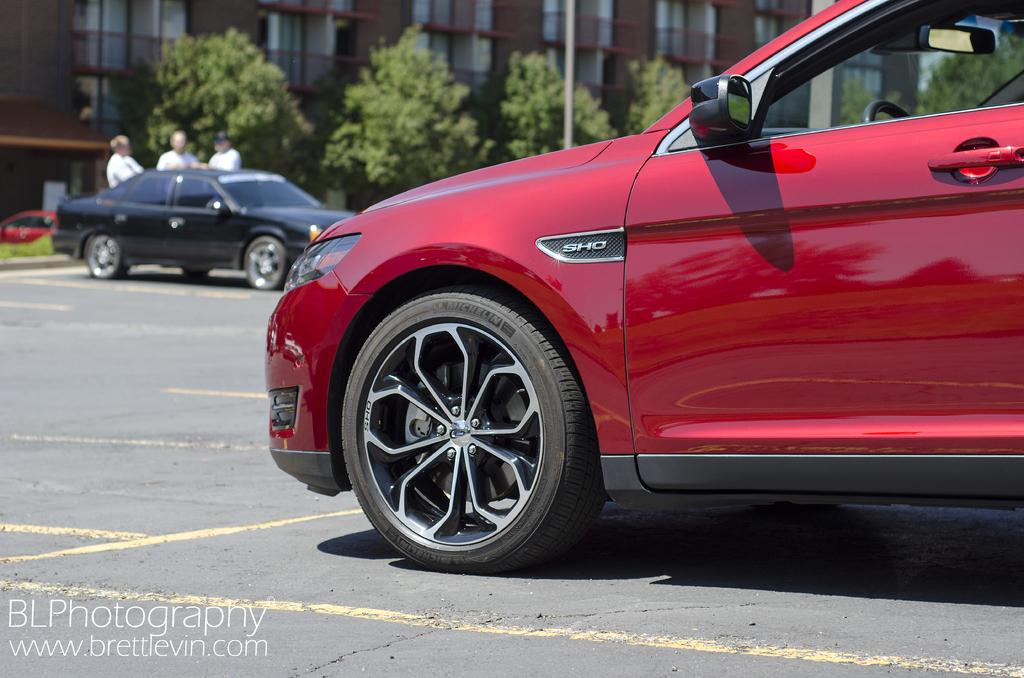What color is the car that is visible on the road in the image? The car on the road is red. What else can be seen on the road in the image? There are no other objects or vehicles visible on the road in the image. What can be seen in the background of the image? In the background of the image, there are cars, trees, a building, and three persons standing. How many cars are visible in the image? There is one car on the road and multiple cars in the background, so there are at least two cars visible in the image. How far away are the trees from the crying person in the image? There is no crying person present in the image, and therefore no distance can be determined. 